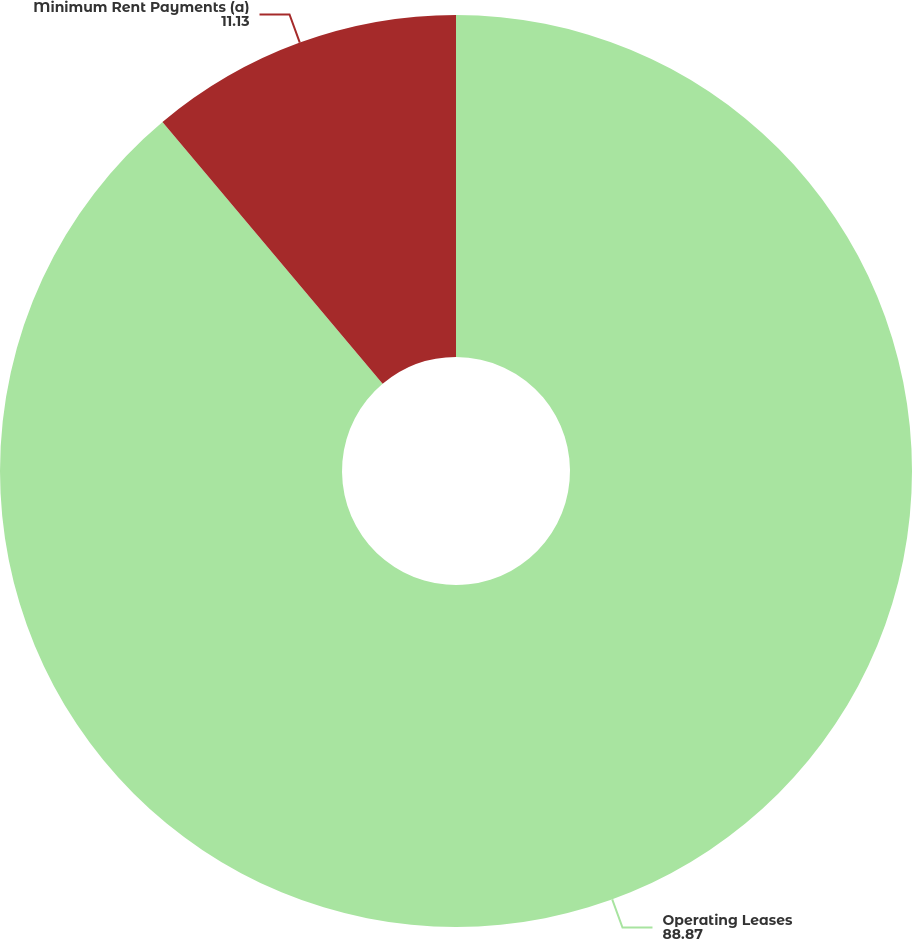Convert chart to OTSL. <chart><loc_0><loc_0><loc_500><loc_500><pie_chart><fcel>Operating Leases<fcel>Minimum Rent Payments (a)<nl><fcel>88.87%<fcel>11.13%<nl></chart> 